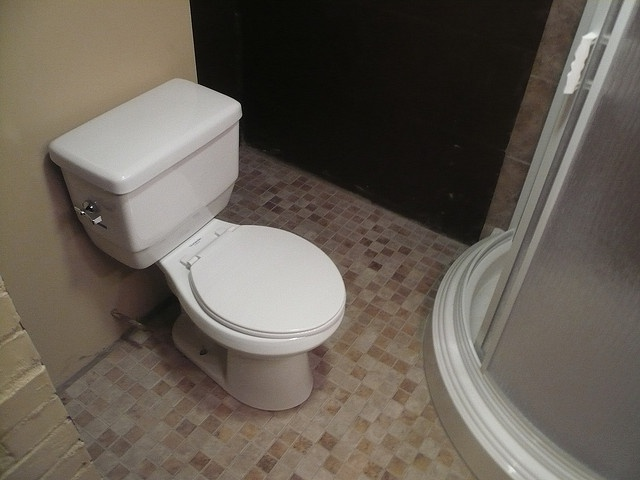Describe the objects in this image and their specific colors. I can see a toilet in gray, darkgray, lightgray, and black tones in this image. 